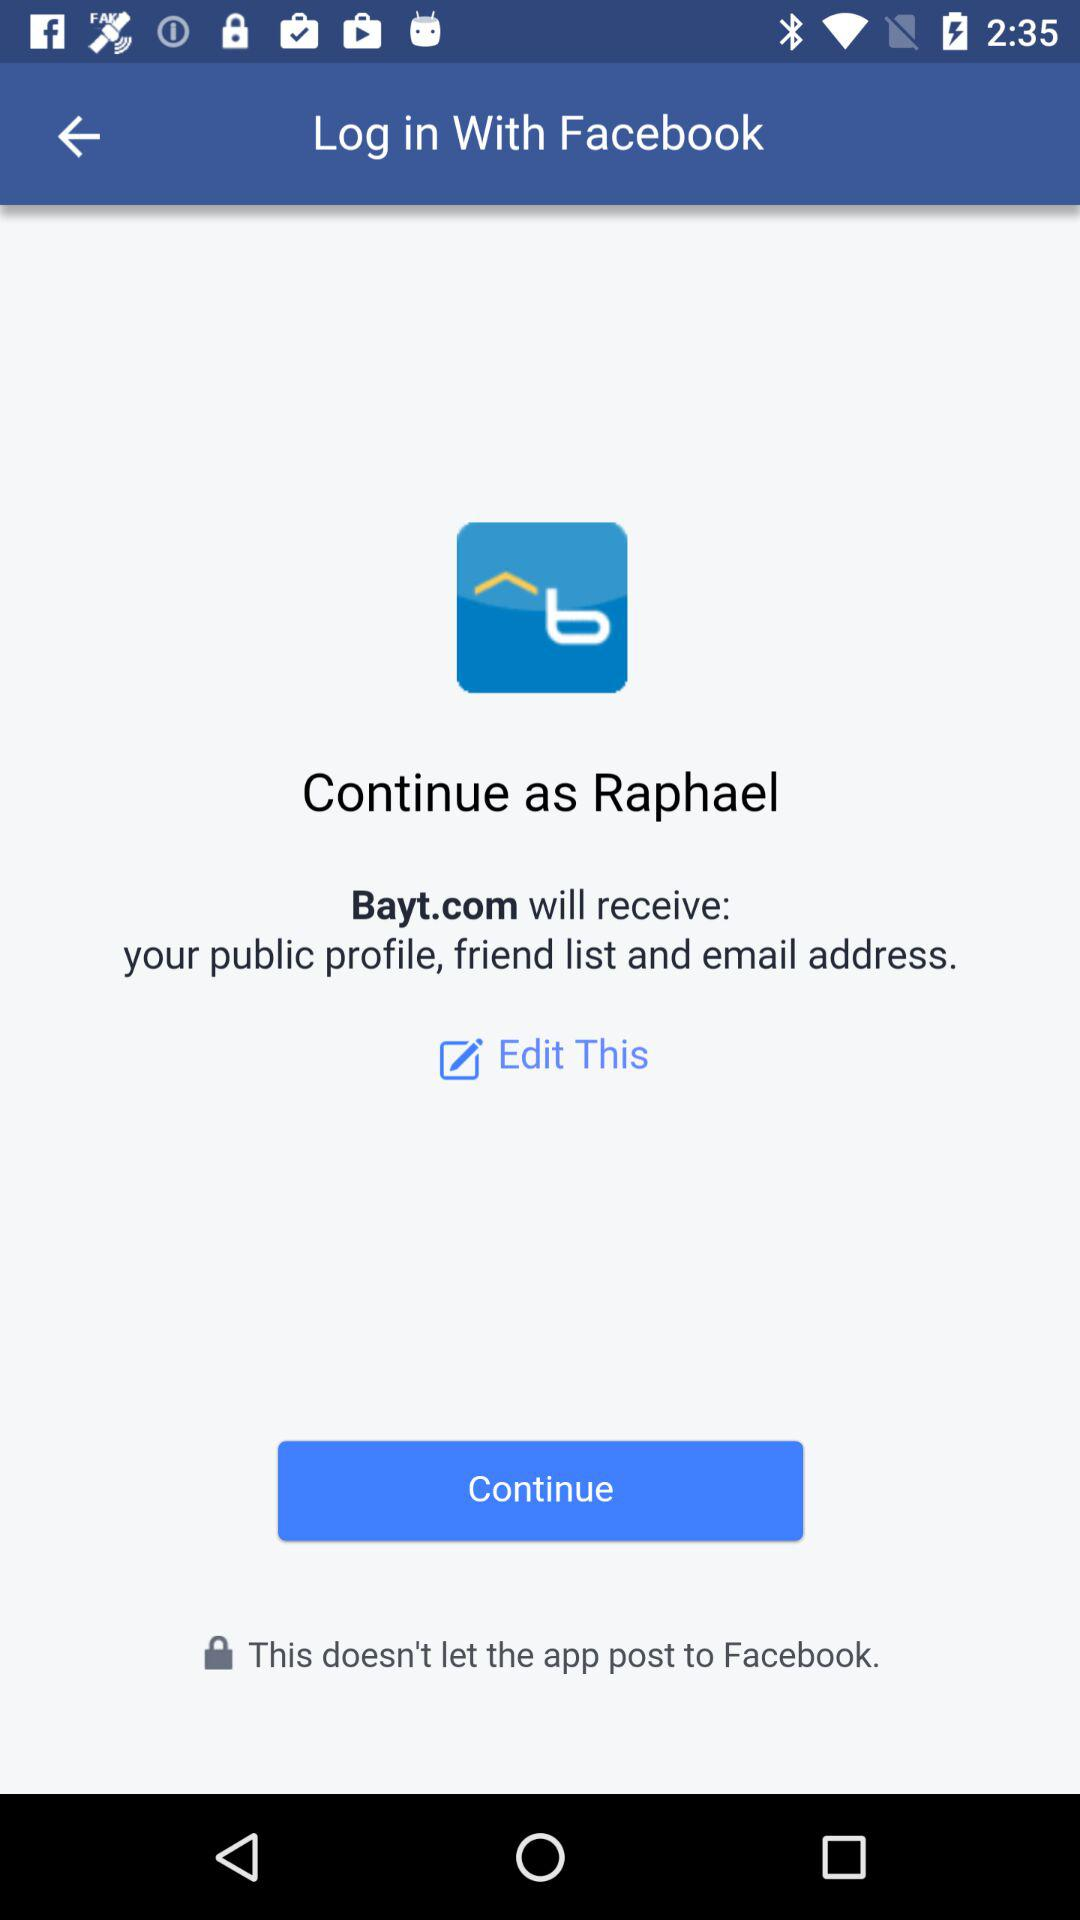Which account am I using for login? You are using "Facebook" account for login. 